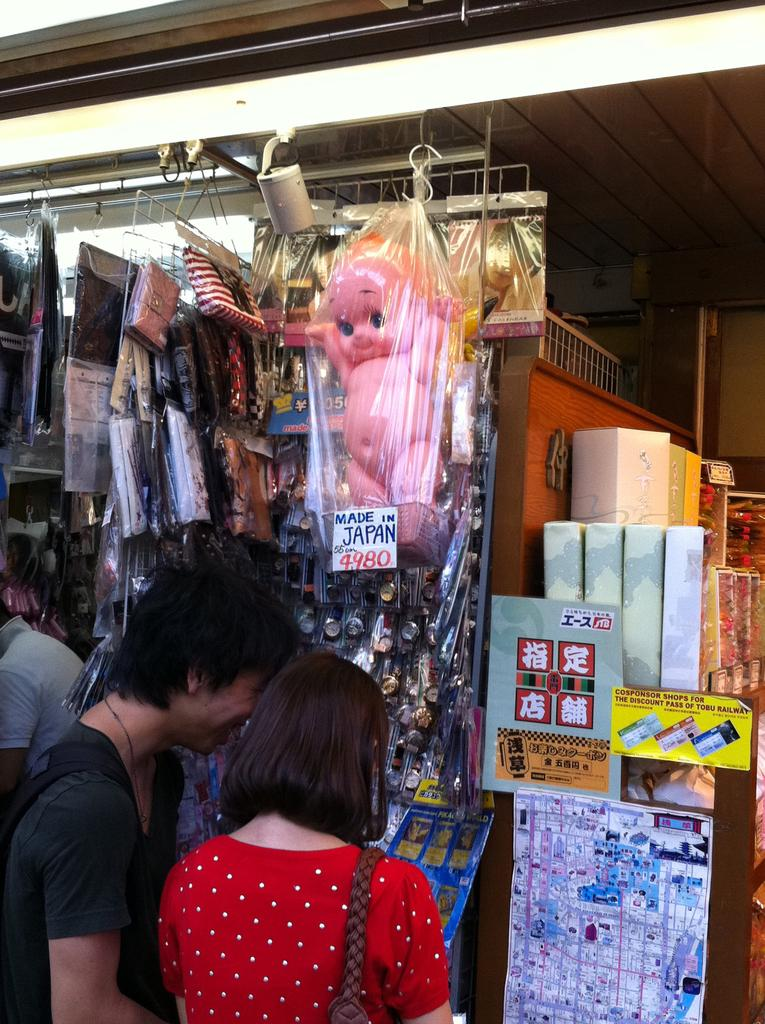Who or what can be seen in the image? There are people in the image. What is the background of the image? There is a wall in the image. What objects are present in the image? There are boxes, a poster, and a doll in the image. How many books are on the shelves in the image? There is no mention of shelves or books in the image, so it is not possible to answer that question. 